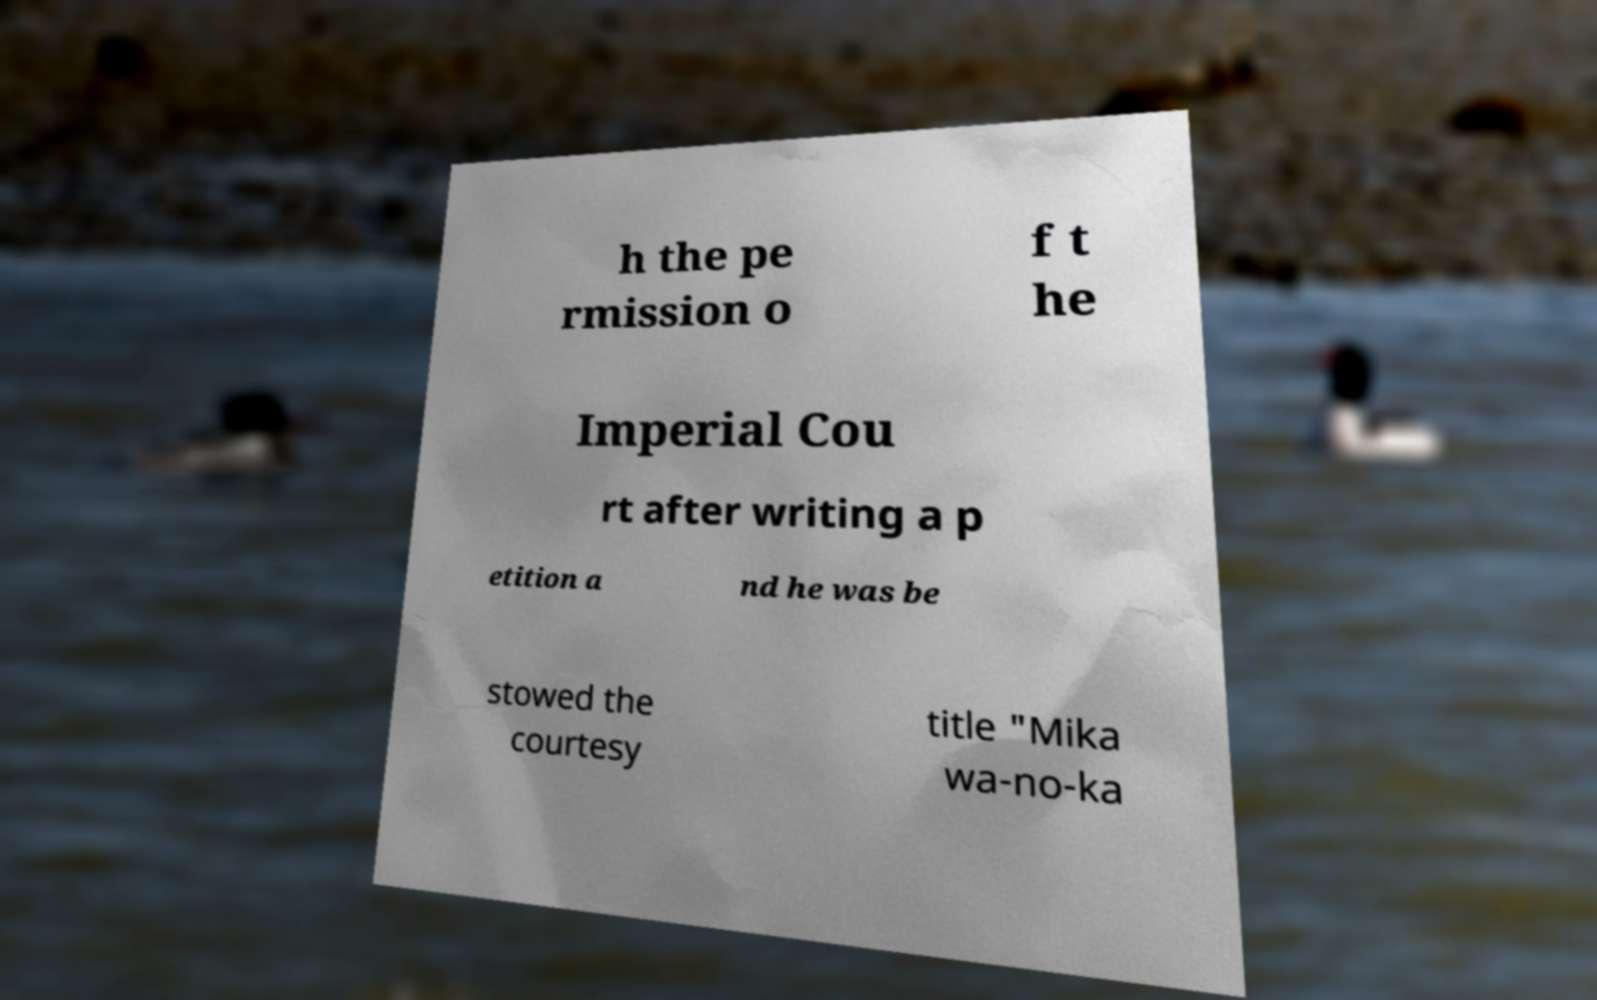Can you read and provide the text displayed in the image?This photo seems to have some interesting text. Can you extract and type it out for me? h the pe rmission o f t he Imperial Cou rt after writing a p etition a nd he was be stowed the courtesy title "Mika wa-no-ka 